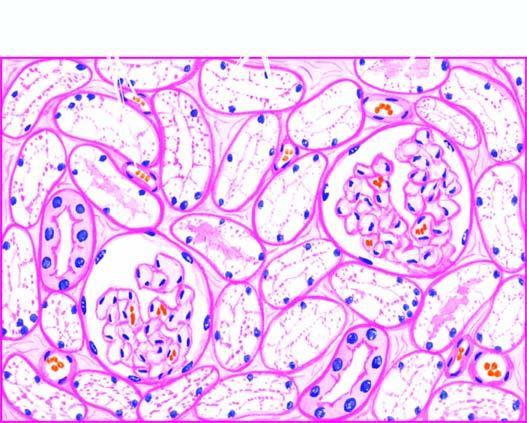re two daughter cells distended with cytoplasmic vacuoles while the interstitial vasculature is compressed?
Answer the question using a single word or phrase. No 